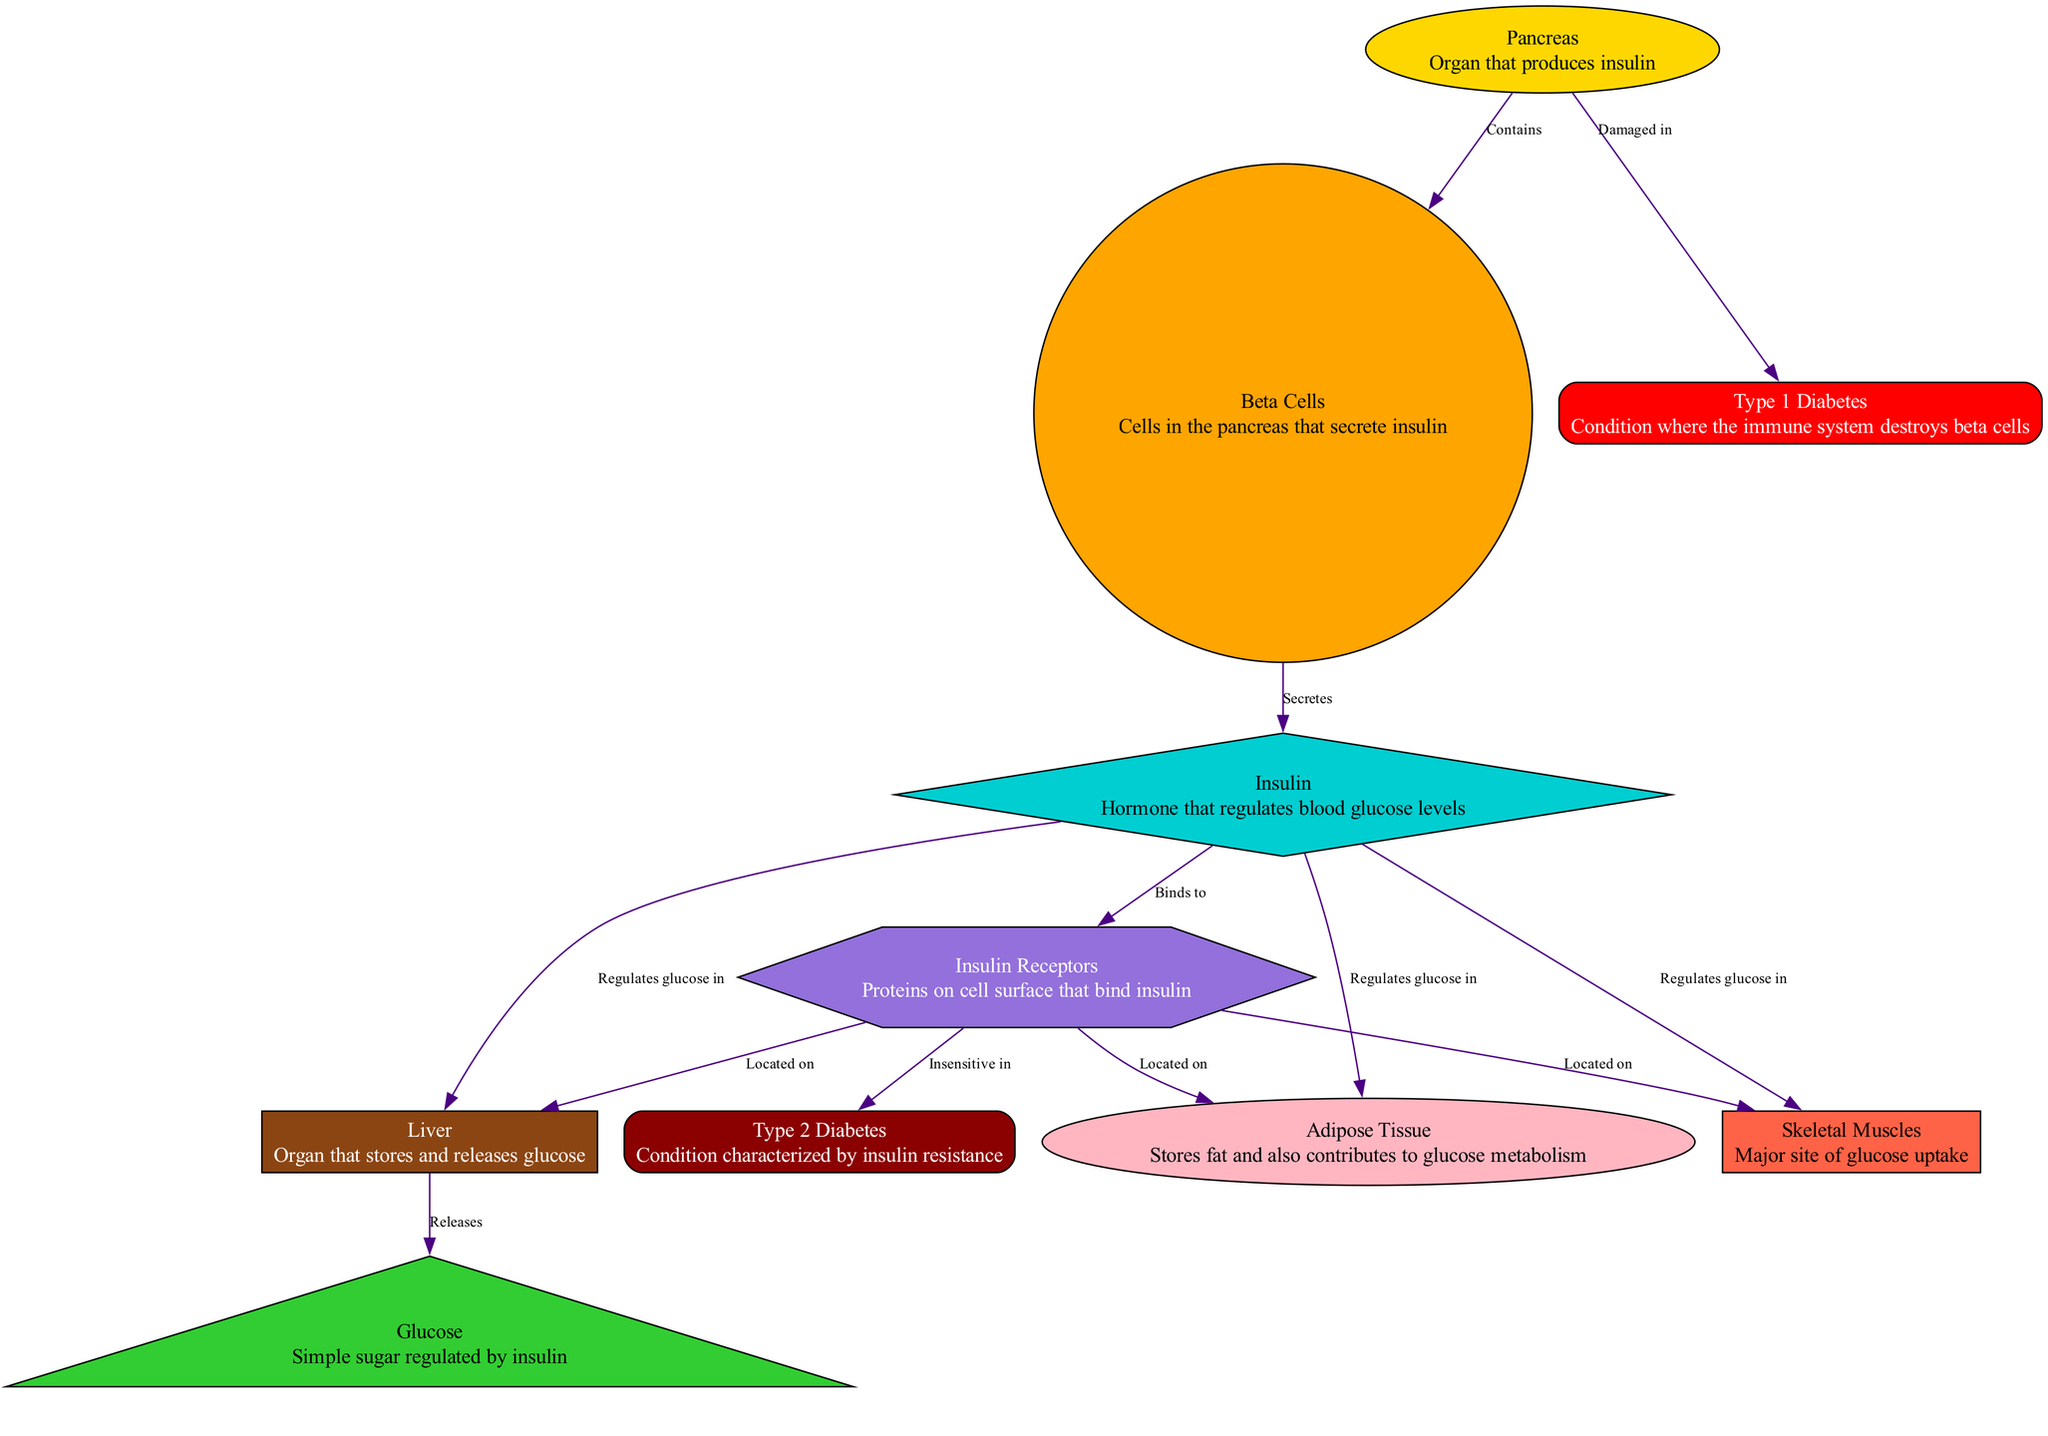What organ produces insulin? The diagram indicates that the organ responsible for the production of insulin is labeled as "Pancreas." The description attached to this node confirms its role in insulin production.
Answer: Pancreas How many insulin receptors are shown in the diagram? The diagram presents a single node labeled "Insulin Receptors." Since there is only one node for this label, the count is one.
Answer: 1 Which cells secrete insulin? The diagram specifies "Beta Cells" as the cells that secrete insulin, as indicated by the relationship showing that beta cells are a part of the pancreas and are responsible for insulin secretion.
Answer: Beta Cells What type of diabetes is characterized by insulin resistance? The node labeled "Type 2 Diabetes" specifies that this condition is marked by insulin resistance. The description attached to this node highlights the defining characteristic of this diabetes type.
Answer: Type 2 Diabetes Which organ releases glucose? According to the diagram, the organ responsible for releasing glucose is labeled as "Liver." The edge from the liver to glucose emphasizes this functionality, indicating its role in glucose release.
Answer: Liver What happens to beta cells in Type 1 diabetes? The diagram states that in Type 1 Diabetes, the condition involves damage to the beta cells, which are marked as the source of insulin. Consequently, the immune system destroys these cells in this type of diabetes.
Answer: Damaged Where do insulin receptors exist? The diagram indicates that insulin receptors are located on the surface of the liver, skeletal muscles, and adipose tissue. Three edges from the insulin receptors demonstrate these relationships.
Answer: Liver, Skeletal Muscles, Adipose Tissue Which hormone regulates blood glucose levels? The diagram explicitly labels "Insulin" as the hormone that regulates blood glucose levels. The relationship arrows confirm its regulatory function in different organs represented.
Answer: Insulin How does insulin affect glucose levels in skeletal muscles? The diagram shows that insulin regulates glucose levels specifically in the skeletal muscles, as indicated by the directed edge from insulin to skeletal muscles, explicitly noting insulin's influence in that area.
Answer: Regulates glucose in What is damaged in Type 1 diabetes? The edge from the pancreas indicates that beta cells are damaged in Type 1 diabetes. The direct relationship specifies the impact that the condition has on the pancreas.
Answer: Beta cells 